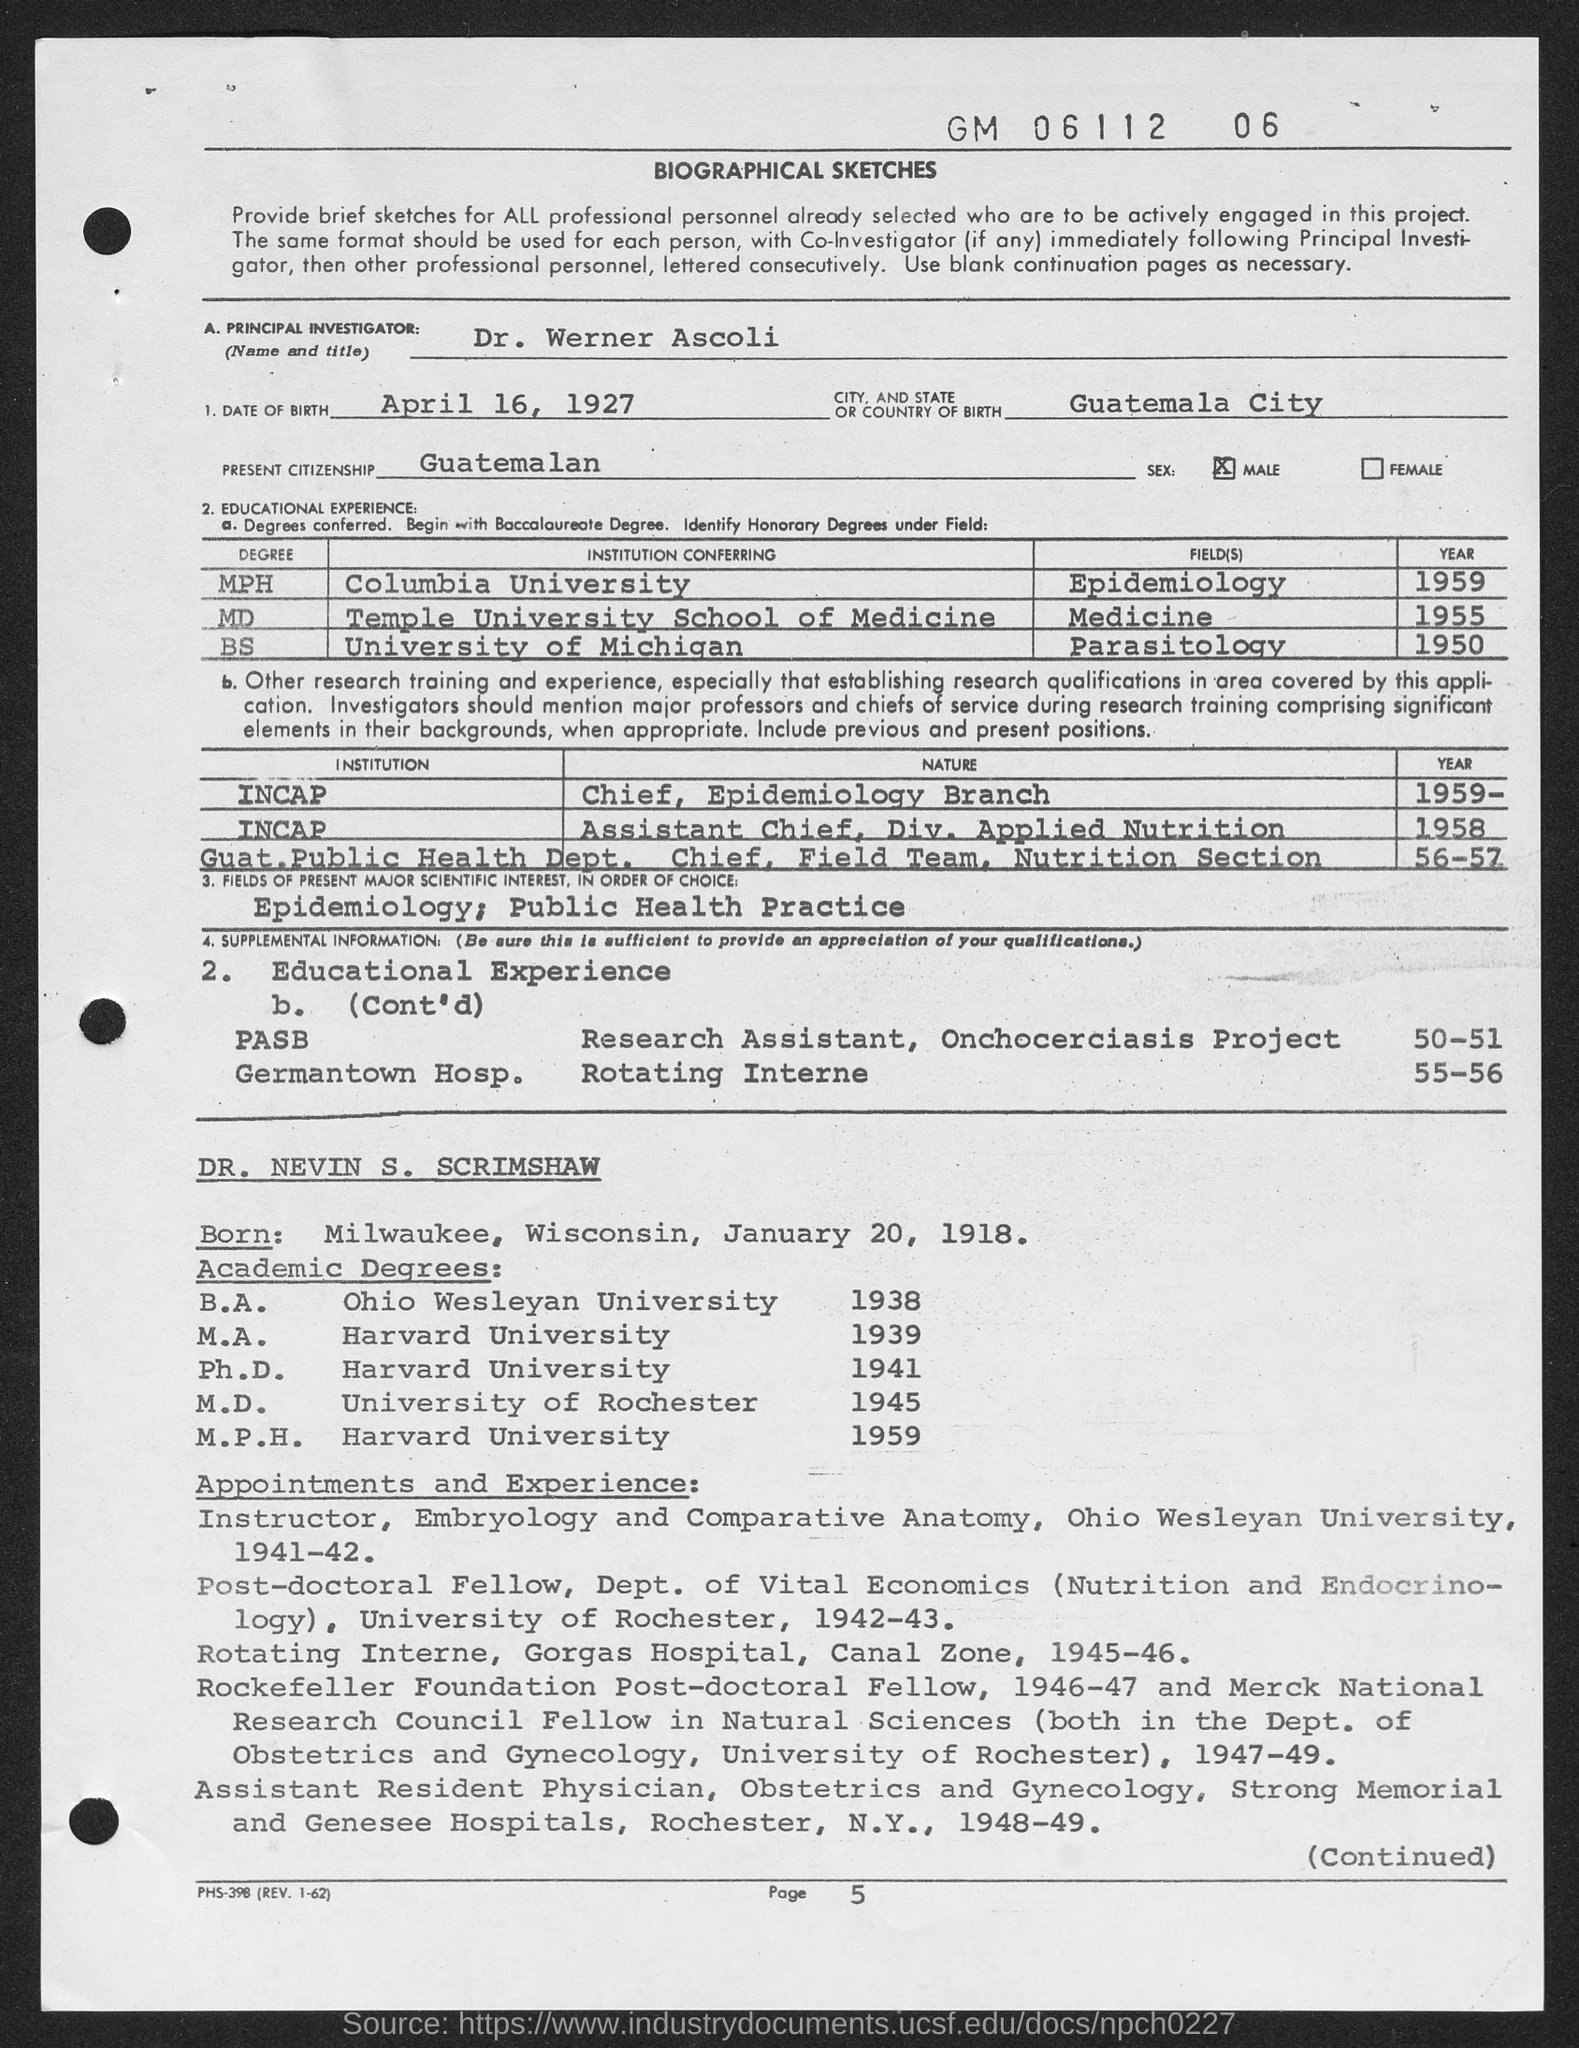Outline some significant characteristics in this image. Dr. Nevin S. Scrimshaw was born on January 20, 1918. Dr. Werner Ascoli's current citizenship is Guatemalan. Dr. Werner Ascoli obtained his BS degree in Parasitology from the University of Michigan. DR. NEVIN S. SCRIMSHAW completed his M.P.H. degree at Harvard University. The principal investigator's name, as mentioned in the document, is Dr. Werner Ascoli. 